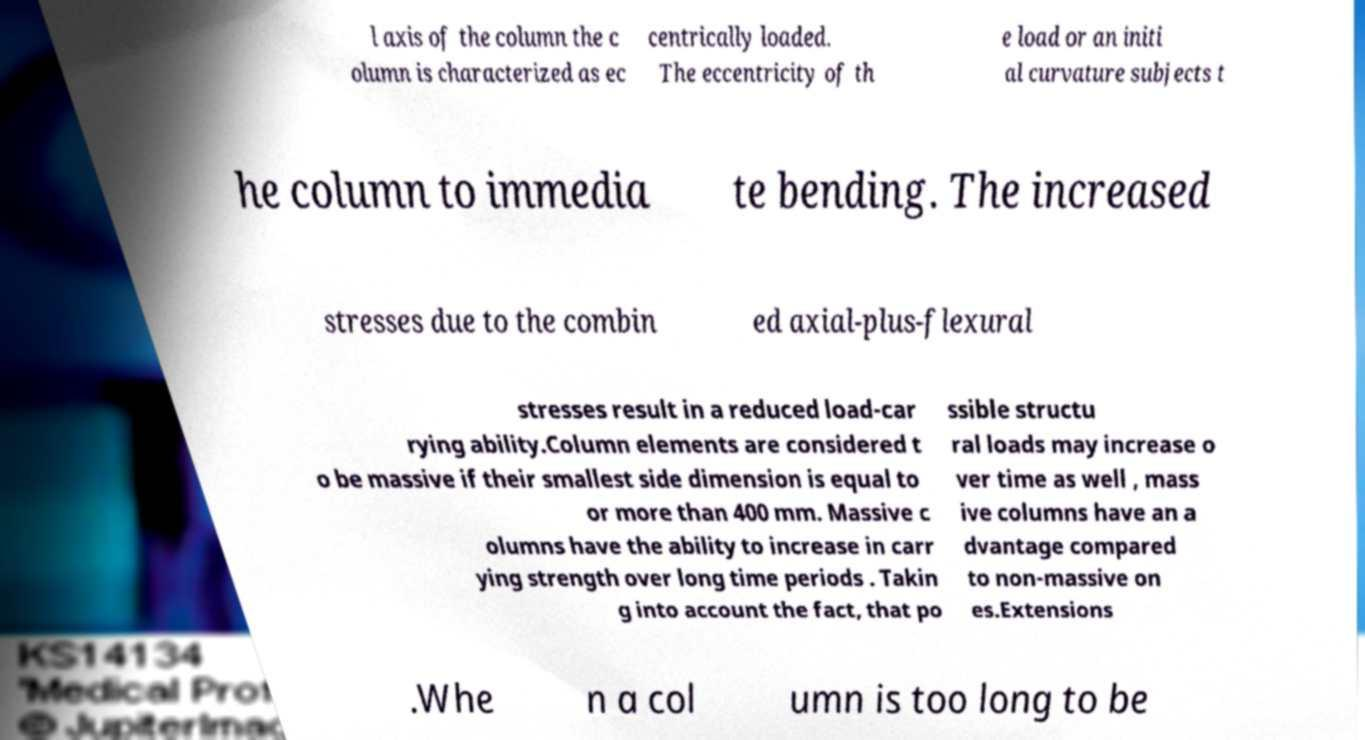Could you assist in decoding the text presented in this image and type it out clearly? l axis of the column the c olumn is characterized as ec centrically loaded. The eccentricity of th e load or an initi al curvature subjects t he column to immedia te bending. The increased stresses due to the combin ed axial-plus-flexural stresses result in a reduced load-car rying ability.Column elements are considered t o be massive if their smallest side dimension is equal to or more than 400 mm. Massive c olumns have the ability to increase in carr ying strength over long time periods . Takin g into account the fact, that po ssible structu ral loads may increase o ver time as well , mass ive columns have an a dvantage compared to non-massive on es.Extensions .Whe n a col umn is too long to be 